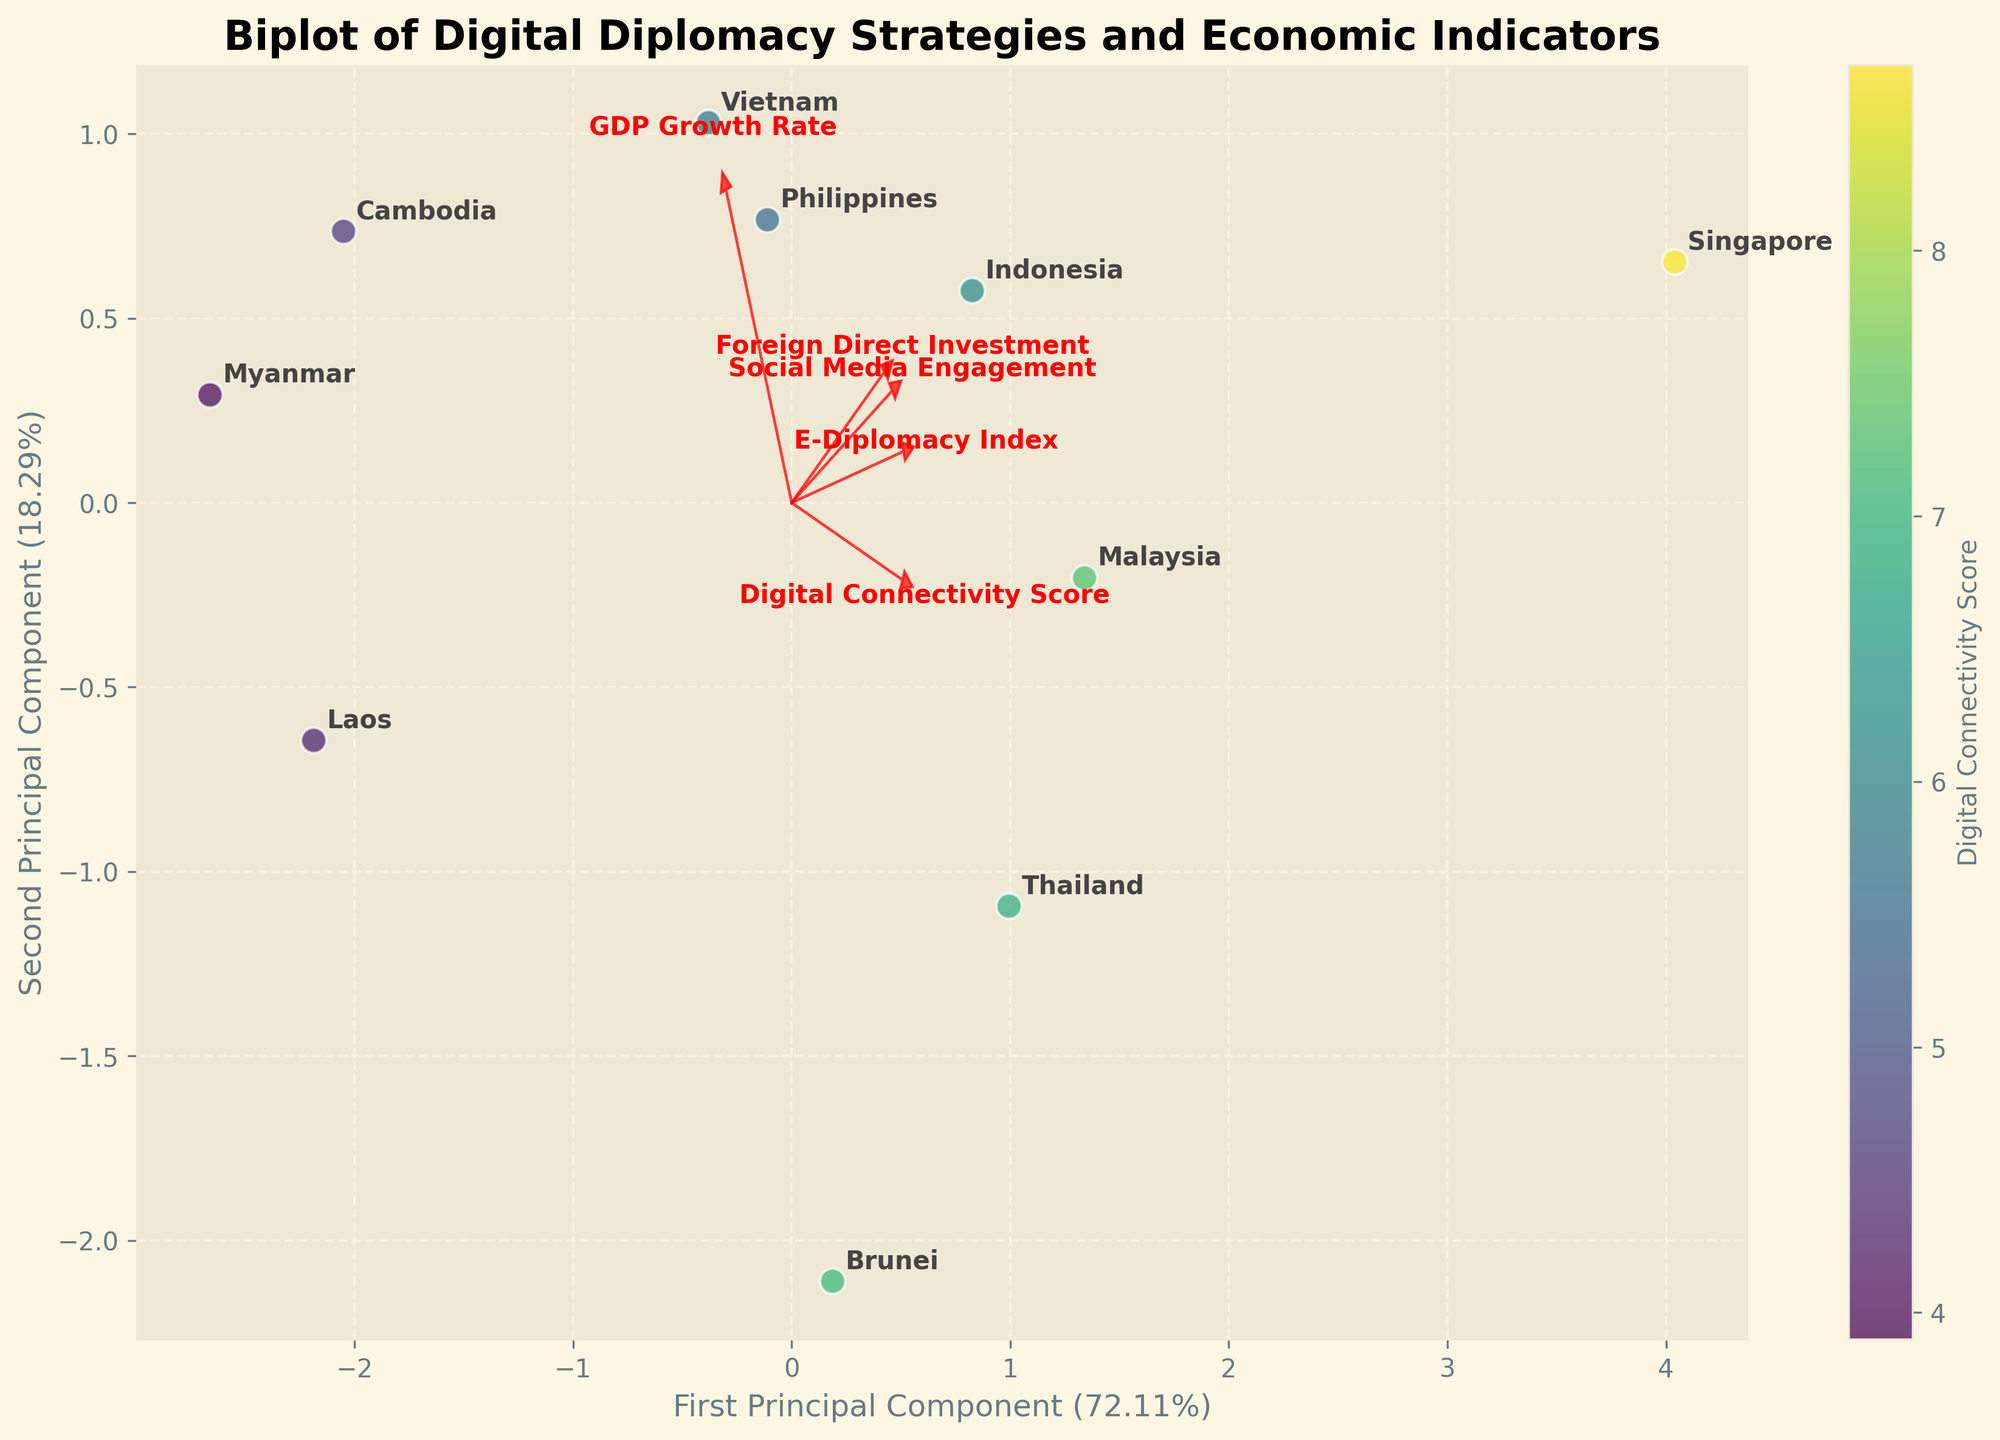What is the title of the figure? The title of the figure is displayed at the top of the plot. It reads "Biplot of Digital Diplomacy Strategies and Economic Indicators."
Answer: Biplot of Digital Diplomacy Strategies and Economic Indicators How many countries are represented in the biplot? Count the number of distinct points or labels in the plot. Each point corresponds to a different country.
Answer: 10 Which principal component explains a higher percentage of the variance? Observe the axis labels for the percentages mentioned. The first principal component has a higher percentage than the second.
Answer: First Principal Component Which country has the highest Digital Connectivity Score, and where is it located on the biplot? Look for the country label closest to the highest color intensity, as indicated by the color scale on the right side of the plot. Singapore has the highest Digital Connectivity Score, and its label is towards the top right of the plot.
Answer: Singapore What are the directions of the arrows for "Social Media Engagement" and "Foreign Direct Investment"? Observe the arrows for these features. The arrow for "Social Media Engagement" points to the right, and the arrow for "Foreign Direct Investment" points downwards.
Answer: Right and Downwards Which feature is most closely associated with the first principal component? Identify the arrow most aligned with the x-axis, representing the first principal component. The 'Social Media Engagement' arrow runs almost parallel to the x-axis.
Answer: Social Media Engagement Between Malaysia and Indonesia, which country appears to have a higher engagement on social media? Compare the labels for Malaysia and Indonesia and their positions relative to the Social Media Engagement arrow. Indonesia is positioned further along the arrow for Social Media Engagement than Malaysia.
Answer: Indonesia What feature is most aligned with the second principal component and what direction does it point? Identify the arrow most aligned with the y-axis, representing the second principal component. The "Digital Connectivity Score" arrow is roughly aligned with the y-axis and points upwards.
Answer: Digital Connectivity Score, Upwards Which two countries are closest to each other in the biplot? Look for two country labels that are nearest to each other in the plot. The Philippines and Vietnam are positioned close to each other.
Answer: Philippines and Vietnam Which feature appears to have the least influence on the biplot structure, based on the length of the arrows? Shorter arrows indicate less influence on the biplot structure. The arrow for "Foreign Direct Investment" is shorter compared to others.
Answer: Foreign Direct Investment 